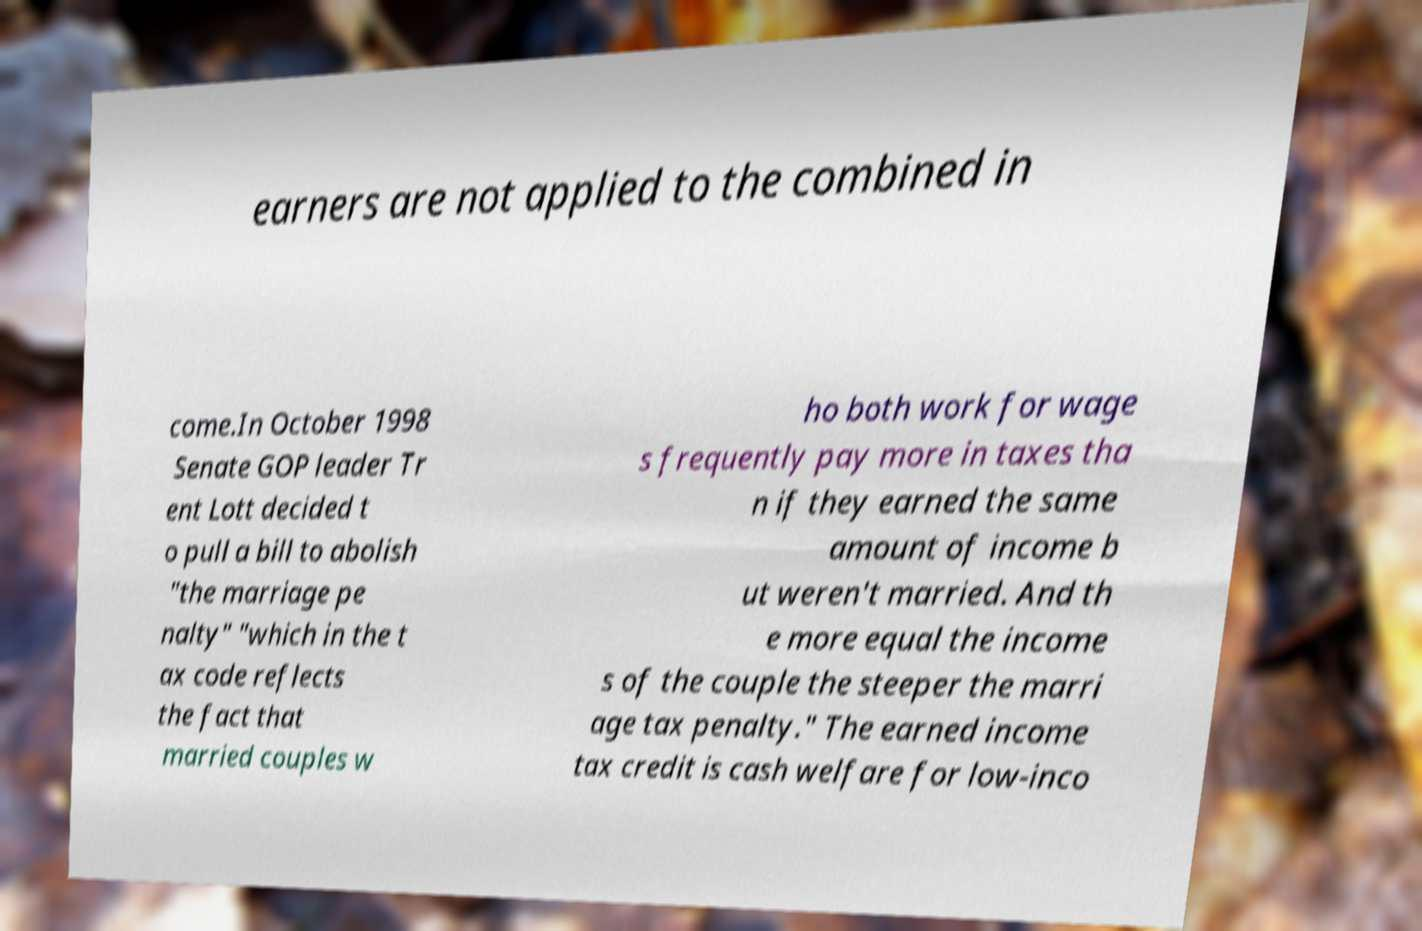Could you extract and type out the text from this image? earners are not applied to the combined in come.In October 1998 Senate GOP leader Tr ent Lott decided t o pull a bill to abolish "the marriage pe nalty" "which in the t ax code reflects the fact that married couples w ho both work for wage s frequently pay more in taxes tha n if they earned the same amount of income b ut weren't married. And th e more equal the income s of the couple the steeper the marri age tax penalty." The earned income tax credit is cash welfare for low-inco 